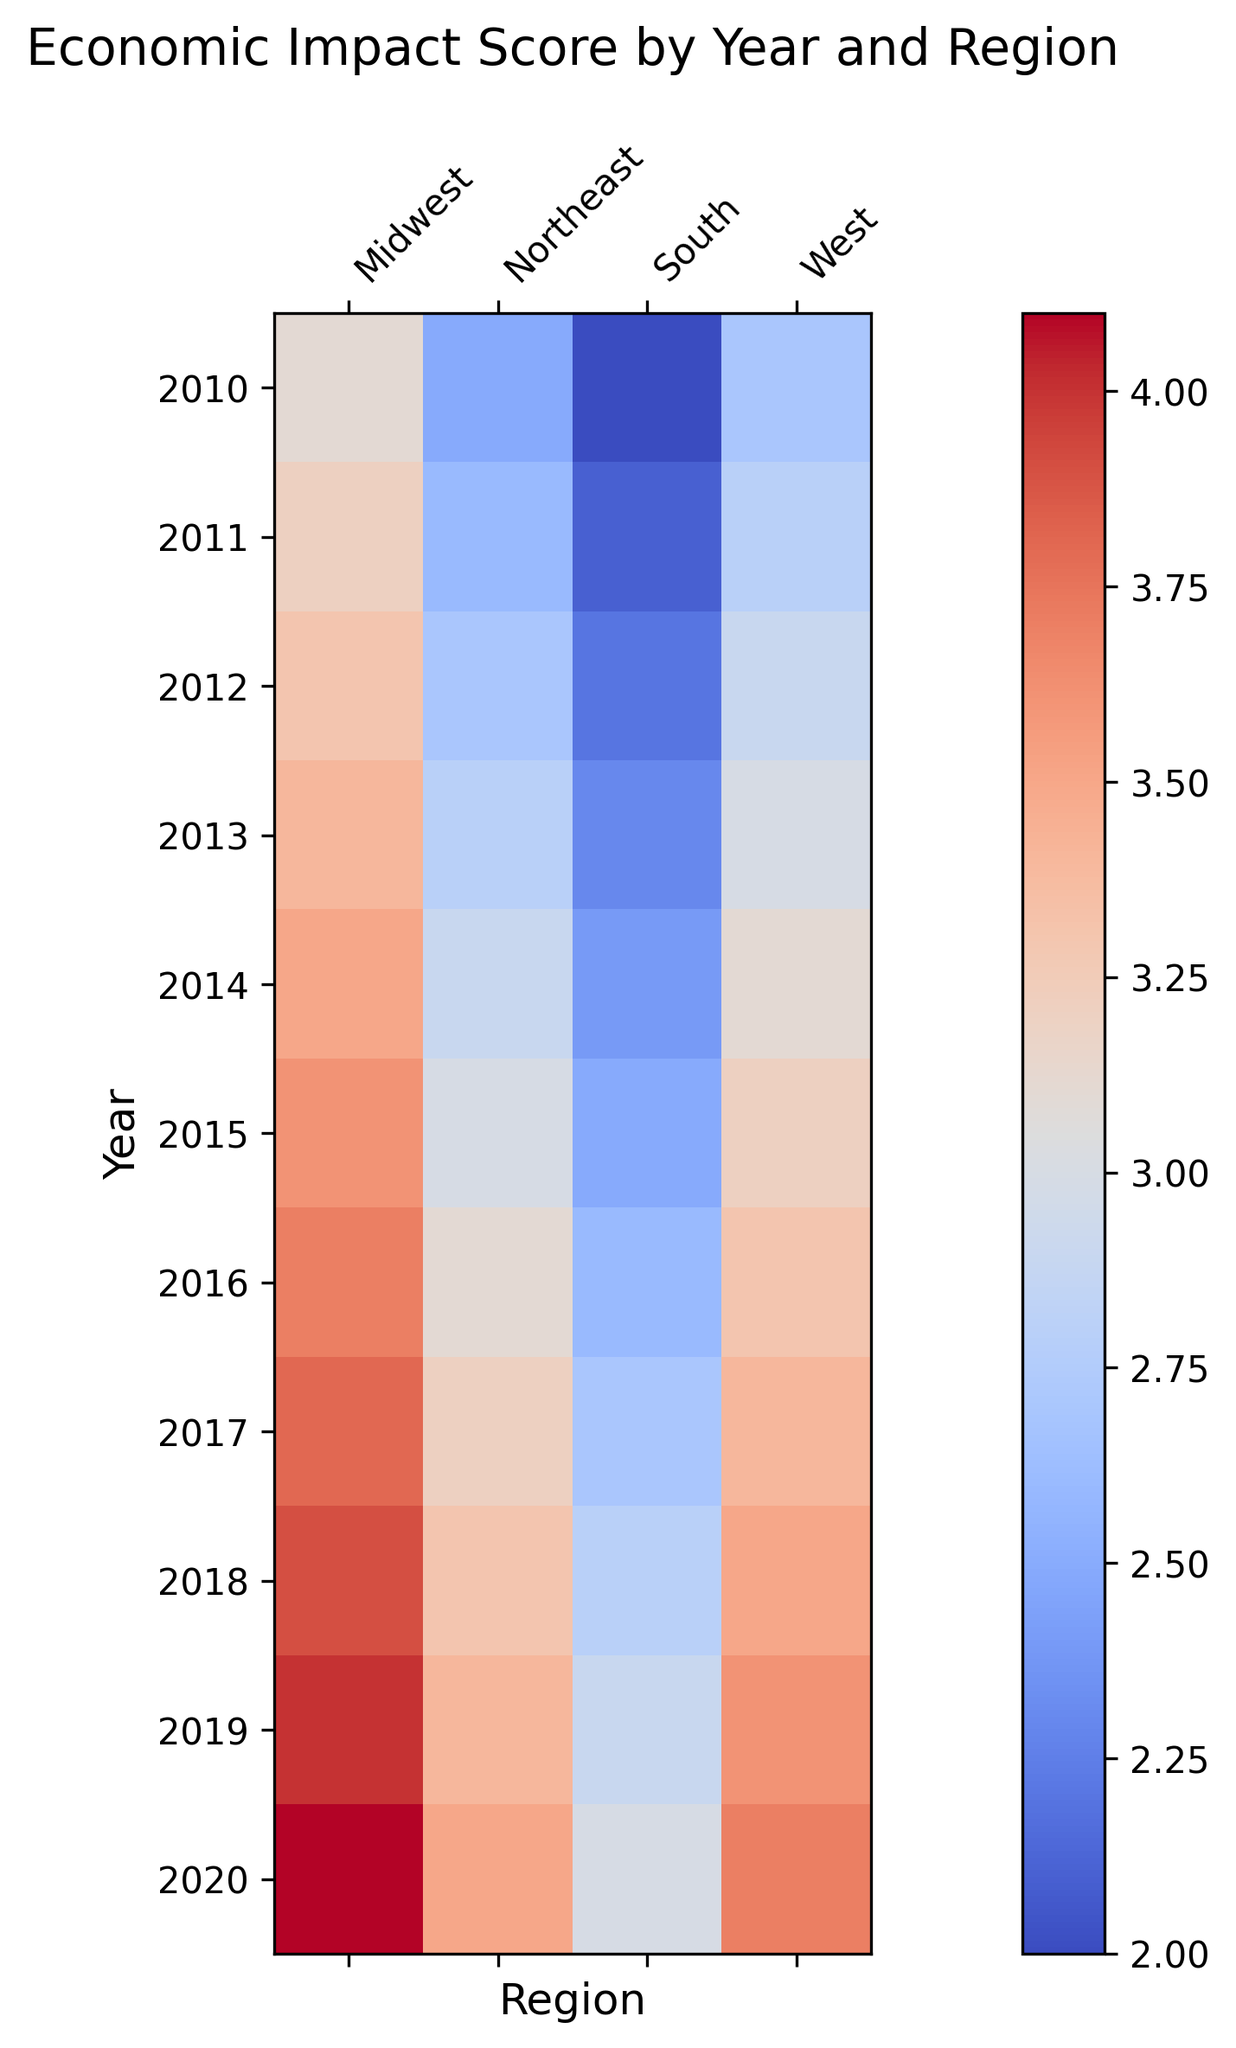Which region had the highest Economic Impact Score in 2020? To determine the highest Economic Impact Score in 2020, look for the darkest or most intense color in that row. The West region has a high score with a deep red hue.
Answer: West Which year had the lowest Economic Impact Score for the Midwest region? To find the lowest score for the Midwest, check the color intensity from 2010 to 2020 for the Midwest column, locating the lightest color. The lightest color appears in 2010.
Answer: 2010 How did the Economic Impact Score for the South region change from 2015 to 2018? Compare the colors for the South region for 2015 and 2018. The color intensity increases from a lighter to a darker shade, indicating an increase in the Economic Impact Score.
Answer: Increased Which region showed the most consistent Economic Impact Score over the years? Examine each column for consistency in color over the years. The South region maintains a fairly uniform light color, indicating relatively stable Economic Impact Scores.
Answer: South What is the overall trend in the Economic Impact Score for the Northeast region? Follow the color gradient for the Northeast region from 2010 to 2020. The shift from lighter to darker colors suggests a general increase in the Economic Impact Score over time.
Answer: Increased In which year did the Economic Impact Score for the West region surpass 3.0? Look for the shift to a darker color in the West region column and trace it back to the years. This shift occurs around 2014.
Answer: 2014 Compare the Economic Impact Score of the Midwest and Northeast regions in 2016. Which region had a higher score? Look at the corresponding positions for 2016 and compare the color intensity. The Midwest region has a darker color than the Northeast, indicating a higher score.
Answer: Midwest What is the difference in the Economic Impact Score of the Northeast region between 2012 and 2019? Identify the color intensity for these years and interpret the values. The color for 2012 is lighter compared to 2019, indicating an increase from 2.7 to 3.4. The difference is 3.4 - 2.7 = 0.7.
Answer: 0.7 Was the Economic Impact Score of the South region ever the highest among all regions? Check the colors for the South region against other regions across all years. The South region consistently has lighter colors, indicating lower scores compared to others.
Answer: No 